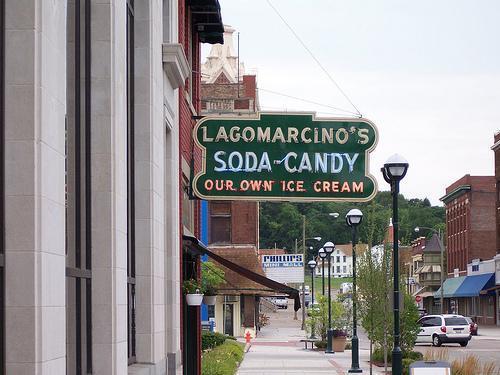How many vehicles are on the road?
Give a very brief answer. 1. 